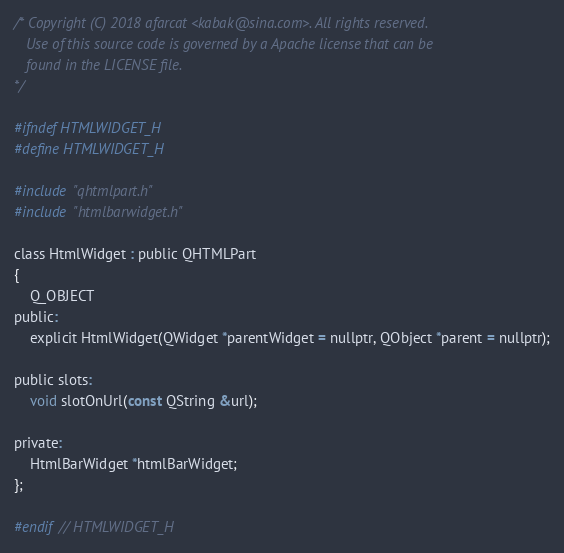<code> <loc_0><loc_0><loc_500><loc_500><_C_>/* Copyright (C) 2018 afarcat <kabak@sina.com>. All rights reserved.
   Use of this source code is governed by a Apache license that can be
   found in the LICENSE file.
*/

#ifndef HTMLWIDGET_H
#define HTMLWIDGET_H

#include "qhtmlpart.h"
#include "htmlbarwidget.h"

class HtmlWidget : public QHTMLPart
{
    Q_OBJECT
public:
    explicit HtmlWidget(QWidget *parentWidget = nullptr, QObject *parent = nullptr);

public slots:
    void slotOnUrl(const QString &url);

private:
    HtmlBarWidget *htmlBarWidget;
};

#endif // HTMLWIDGET_H
</code> 